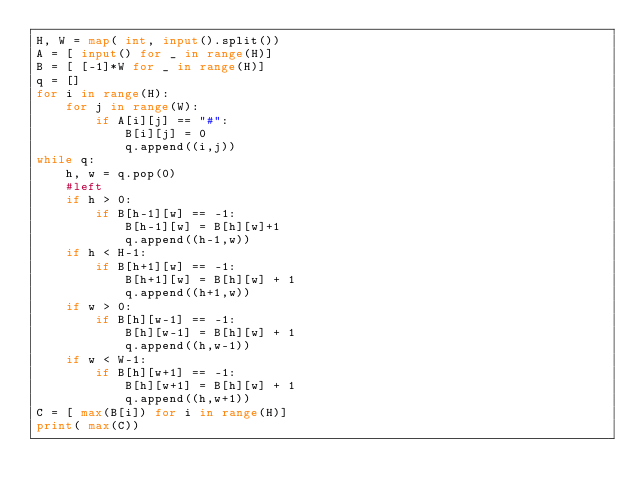<code> <loc_0><loc_0><loc_500><loc_500><_Python_>H, W = map( int, input().split())
A = [ input() for _ in range(H)]
B = [ [-1]*W for _ in range(H)]
q = []
for i in range(H):
    for j in range(W):
        if A[i][j] == "#":
            B[i][j] = 0
            q.append((i,j))
while q:
    h, w = q.pop(0)
    #left
    if h > 0:
        if B[h-1][w] == -1:
            B[h-1][w] = B[h][w]+1
            q.append((h-1,w))
    if h < H-1:
        if B[h+1][w] == -1:
            B[h+1][w] = B[h][w] + 1
            q.append((h+1,w))
    if w > 0:
        if B[h][w-1] == -1:
            B[h][w-1] = B[h][w] + 1
            q.append((h,w-1))
    if w < W-1:
        if B[h][w+1] == -1:
            B[h][w+1] = B[h][w] + 1
            q.append((h,w+1))
C = [ max(B[i]) for i in range(H)]
print( max(C))</code> 